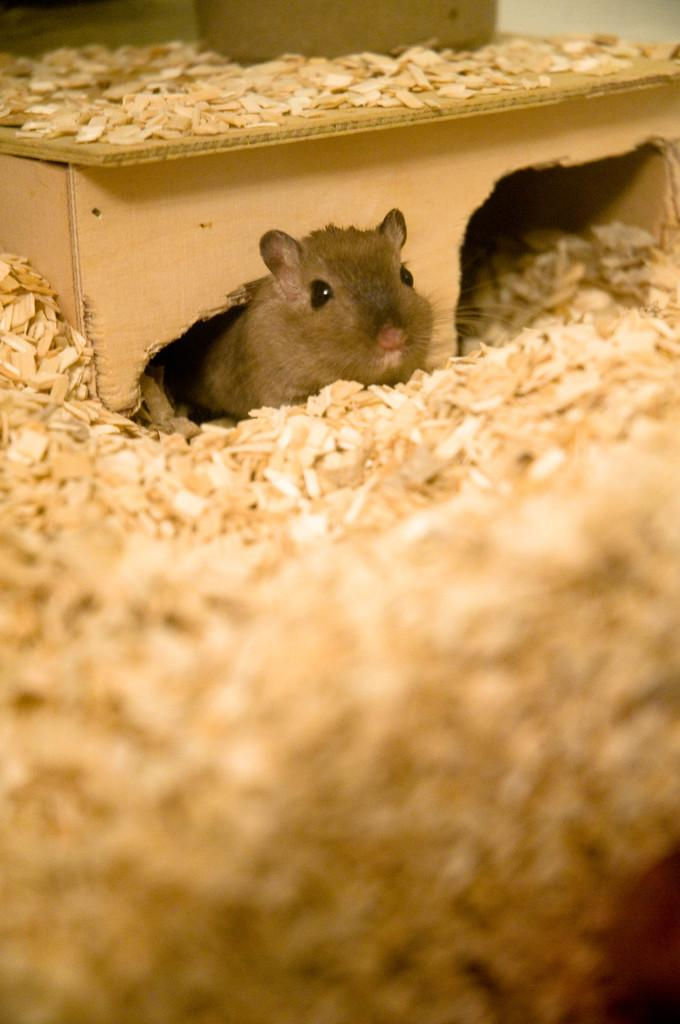What animal is present in the image? There is a rat in the image. Where is the rat located in the image? The rat is under a wooden object. What type of object is the rat under? The wooden object has pieces of wood on it. Are there any other wooden objects or pieces in the image? Yes, there are pieces of wood scattered throughout the image. What type of test is the rat conducting in the image? There is no test being conducted in the image; it simply shows a rat under a wooden object with scattered pieces of wood. 